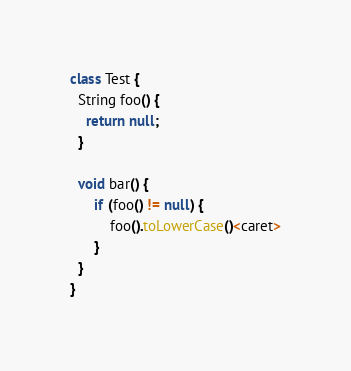Convert code to text. <code><loc_0><loc_0><loc_500><loc_500><_Java_>
class Test {
  String foo() {
    return null;
  }
  
  void bar() {
      if (foo() != null) {
          foo().toLowerCase()<caret>
      }
  }
}</code> 